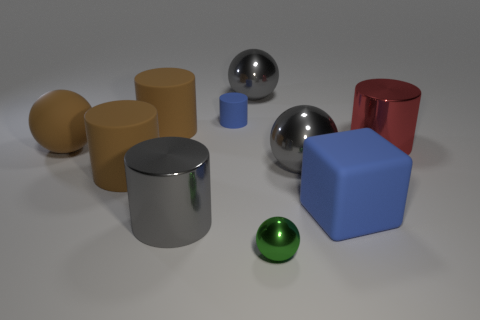How many matte blocks have the same color as the tiny cylinder?
Give a very brief answer. 1. What number of things are metal things that are on the left side of the blue rubber cylinder or matte things left of the big gray shiny cylinder?
Provide a succinct answer. 4. Are there fewer cubes that are on the left side of the blue cylinder than green spheres?
Your answer should be compact. Yes. Is there a gray metallic sphere that has the same size as the green sphere?
Your answer should be very brief. No. The tiny metallic ball is what color?
Your answer should be compact. Green. Do the green metal object and the cube have the same size?
Your answer should be compact. No. How many objects are either green metallic things or large gray shiny spheres?
Your response must be concise. 3. Is the number of small green shiny spheres that are behind the small green metallic object the same as the number of big balls?
Your answer should be very brief. No. Is there a big object that is in front of the brown cylinder that is behind the shiny thing on the right side of the block?
Make the answer very short. Yes. What color is the cube that is the same material as the brown ball?
Give a very brief answer. Blue. 